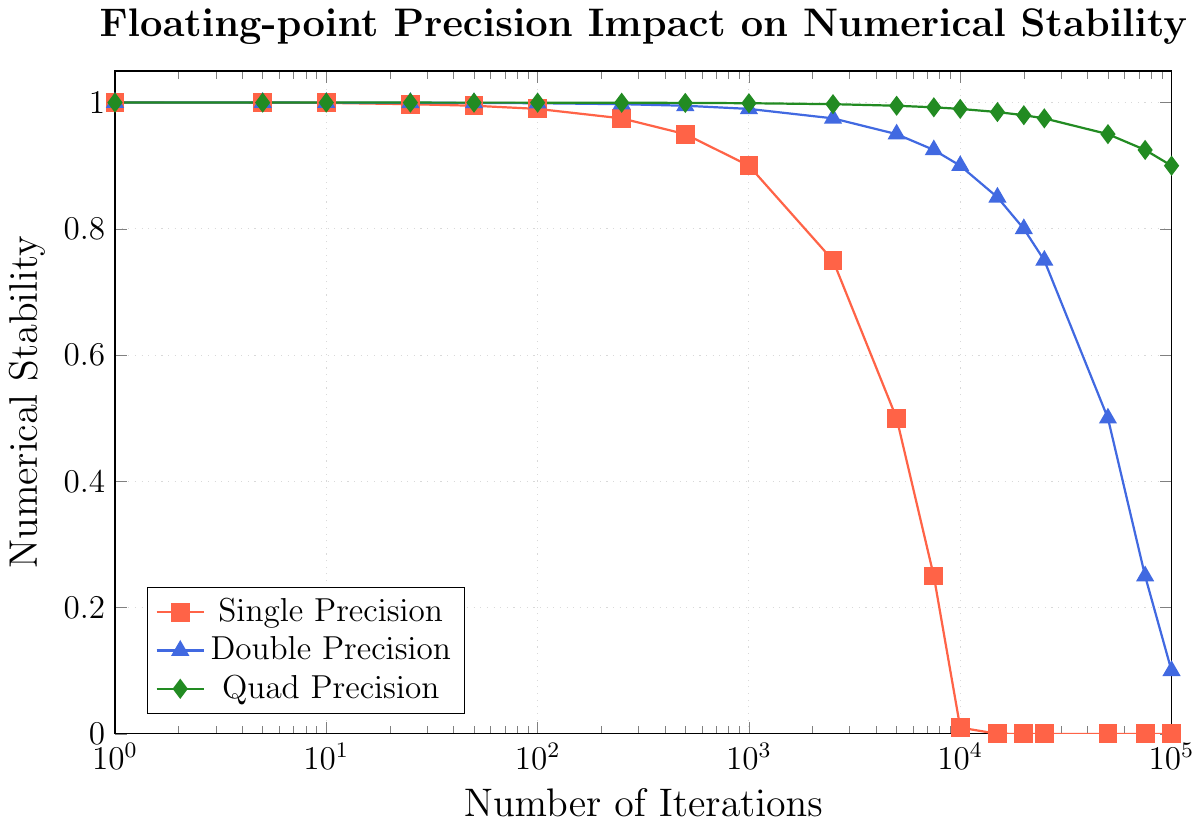Which iterative method retains the highest numerical stability after 50,000 iterations? The plot shows three precision types: single, double, and quad. Look at the numerical stability value for each at 50,000 iterations. Quad precision shows a stability around 0.95, double precision around 0.5, and single precision around 0.0. Quad precision retains the highest numerical stability.
Answer: Quad precision What is the difference in numerical stability between single and double precision at 1,000 iterations? Check the stability for single and double precision at 1,000 iterations. Single precision is at 0.9, and double precision is at 0.99. The difference is 0.99 - 0.9 = 0.09.
Answer: 0.09 Which precision type shows the most significant decline in stability first? Compare where the numerical stability for each precision type first drops significantly. Single precision starts declining sharply around 10,000 iterations, while double and quad remain relatively stable much longer.
Answer: Single precision How much does the numerical stability of quad precision decrease between 1,000 and 25,000 iterations? Look at the values for quad precision at 1,000 and 25,000 iterations. At 1,000, it is 0.999, and at 25,000, it is 0.975. The decrease is 0.999 - 0.975 = 0.024.
Answer: 0.024 By what factor does the numerical stability of double precision decrease from 5,000 to 100,000 iterations? Stability for double precision is approximately 0.95 at 5,000 iterations and 0.1 at 100,000 iterations. The factor decrease is 0.95 / 0.1 = 9.5.
Answer: 9.5 At what iteration count does quad precision first reach a stability level below 0.995? Following the quad precision curve, it first goes below 0.995 slightly after 5,000 iterations, specifically around 7,500 iterations where the stability is approximately 0.9925.
Answer: 7,500 How does the pattern of stability decline differ between single and double precision over the entire range of iterations? Observe the overall trends. Single precision declines rapidly and becomes zero by 25,000 iterations. Double precision decreases more slowly and maintains non-zero values up to 100,000 iterations.
Answer: Single precision declines rapidly, while double declines more slowly 